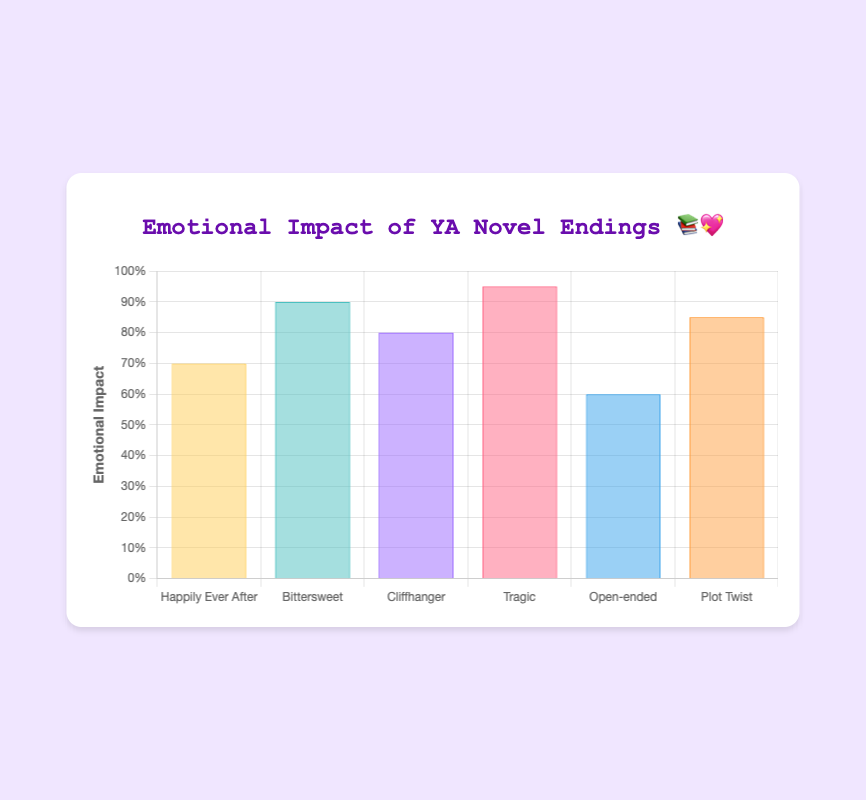What type of YA novel ending has the highest emotional impact? The bar representing 'Tragic' endings is the highest, indicating it has the highest emotional impact.
Answer: Tragic Which ending types have an emotional impact rating equal to or greater than 0.8? The ratings are: Happily Ever After (0.7), Bittersweet (0.9), Cliffhanger (0.8), Tragic (0.95), Open-ended (0.6), and Plot Twist (0.85). The types with ratings equal to or greater than 0.8 are Bittersweet, Cliffhanger, Tragic, and Plot Twist.
Answer: Bittersweet, Cliffhanger, Tragic, Plot Twist How does the emotional impact of 'Cliffhanger' endings compare to 'Plot Twist' endings? 'Cliffhanger' has an emotional impact rating of 0.8, while 'Plot Twist' has a rating of 0.85. Therefore, 'Plot Twist' has a slightly higher emotional impact.
Answer: Plot Twist > Cliffhanger What is the range of emotional impact ratings for these YA novel endings? The highest rating is for 'Tragic' (0.95) and the lowest is for 'Open-ended' (0.6). The range is calculated by subtracting the lowest from the highest rating: 0.95 - 0.6 = 0.35.
Answer: 0.35 Which type of YA novel ending has a lower emotional impact: 'Open-ended' or 'Happily Ever After'? The emotional impact ratings are 0.6 for 'Open-ended' and 0.7 for 'Happily Ever After'. Therefore, 'Open-ended' has a lower emotional impact.
Answer: Open-ended What percentage of the maximum possible emotional impact does 'Bittersweet' achieve? The maximum possible emotional impact is 1. The 'Bittersweet' rating is 0.9, which is 90% of 1 (0.9 * 100).
Answer: 90% How much higher is the emotional impact of 'Tragic' endings compared to 'Open-ended' endings? The emotional impact for 'Tragic' is 0.95 and for 'Open-ended' is 0.6. The difference is 0.95 - 0.6 = 0.35.
Answer: 0.35 What is the average emotional impact rating for all the YA novel endings listed? Add all ratings: 0.7 (Happily Ever After) + 0.9 (Bittersweet) + 0.8 (Cliffhanger) + 0.95 (Tragic) + 0.6 (Open-ended) + 0.85 (Plot Twist). The sum is 4.8. Divide by the number of endings (6): 4.8 / 6 = 0.8.
Answer: 0.8 